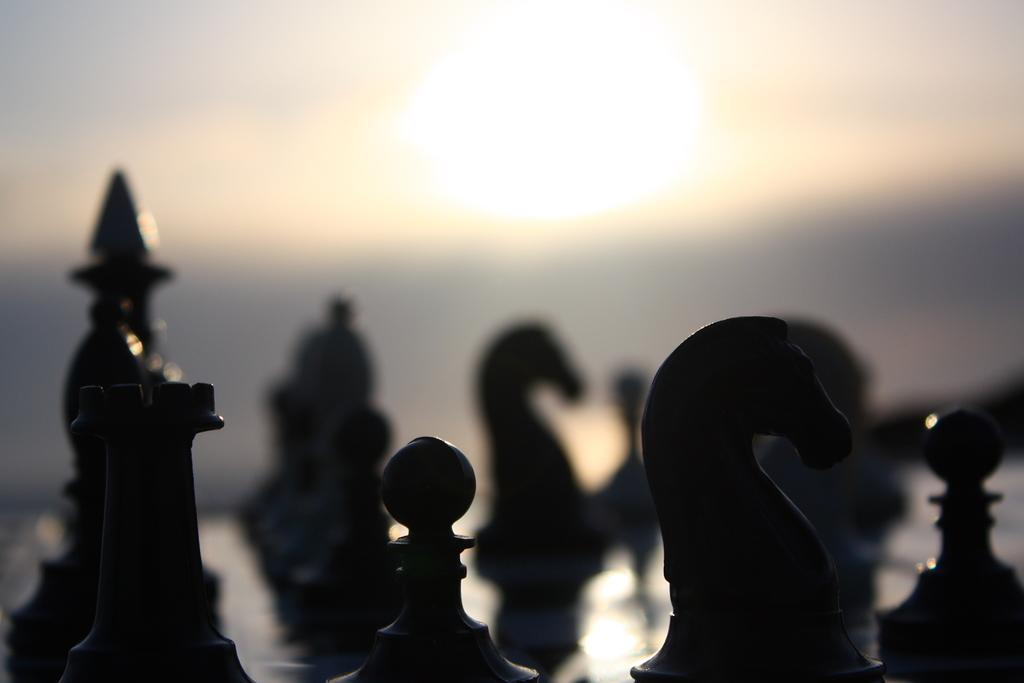What is the main subject of the image? The main subject of the image is a chess board. Can you describe the chess board in the image? The chess board is visible in the image. Where is the dock located in the image? There is no dock present in the image; it features a chess board. Can you describe the cat playing with the chess pieces in the image? There is no cat present in the image; it features a chess board. 